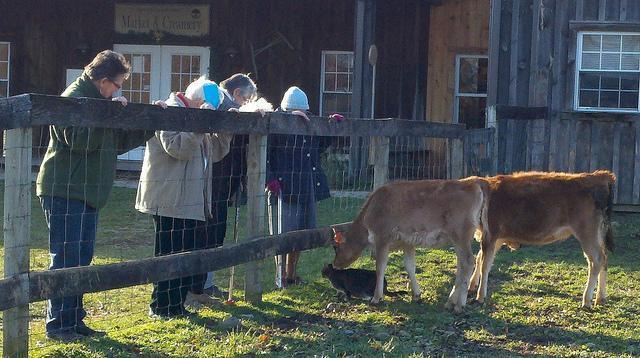How many human figures are in the photo?
Give a very brief answer. 4. How many people are there?
Give a very brief answer. 4. How many cows can you see?
Give a very brief answer. 2. 